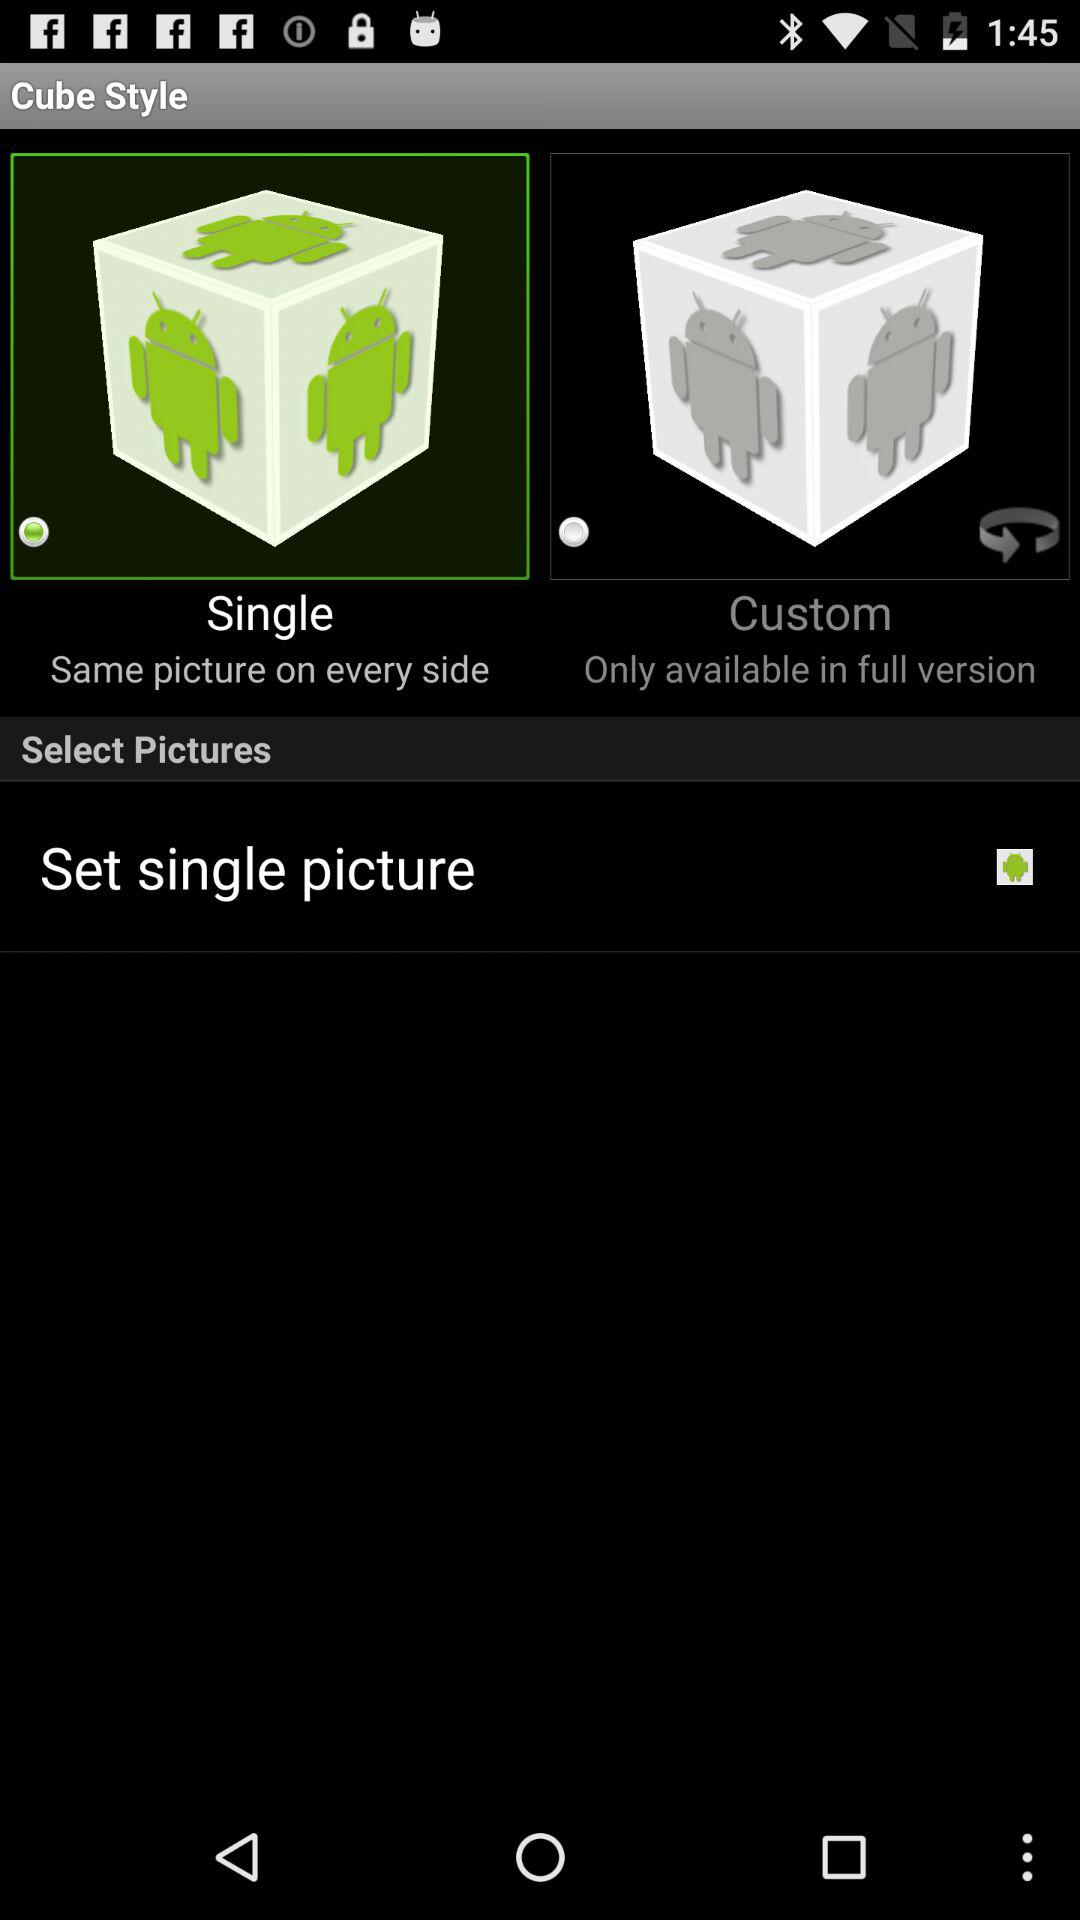What's the status for Set single picture?
When the provided information is insufficient, respond with <no answer>. <no answer> 